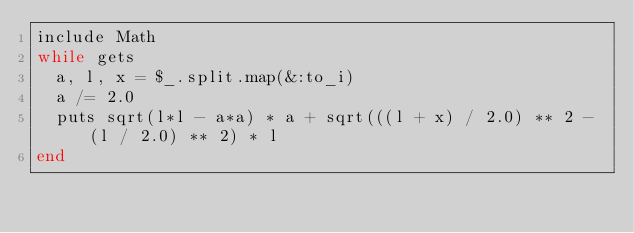<code> <loc_0><loc_0><loc_500><loc_500><_Ruby_>include Math
while gets
  a, l, x = $_.split.map(&:to_i)
  a /= 2.0
  puts sqrt(l*l - a*a) * a + sqrt(((l + x) / 2.0) ** 2 - (l / 2.0) ** 2) * l
end</code> 